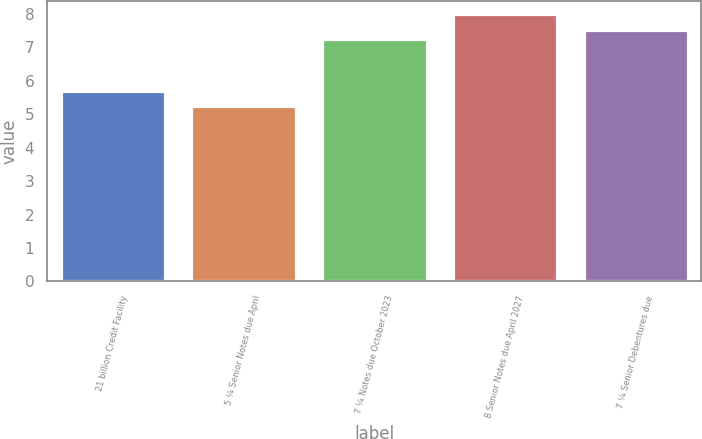Convert chart to OTSL. <chart><loc_0><loc_0><loc_500><loc_500><bar_chart><fcel>21 billion Credit Facility<fcel>5 ¼ Senior Notes due April<fcel>7 ¼ Notes due October 2023<fcel>8 Senior Notes due April 2027<fcel>7 ¼ Senior Debentures due<nl><fcel>5.69<fcel>5.25<fcel>7.25<fcel>8<fcel>7.53<nl></chart> 